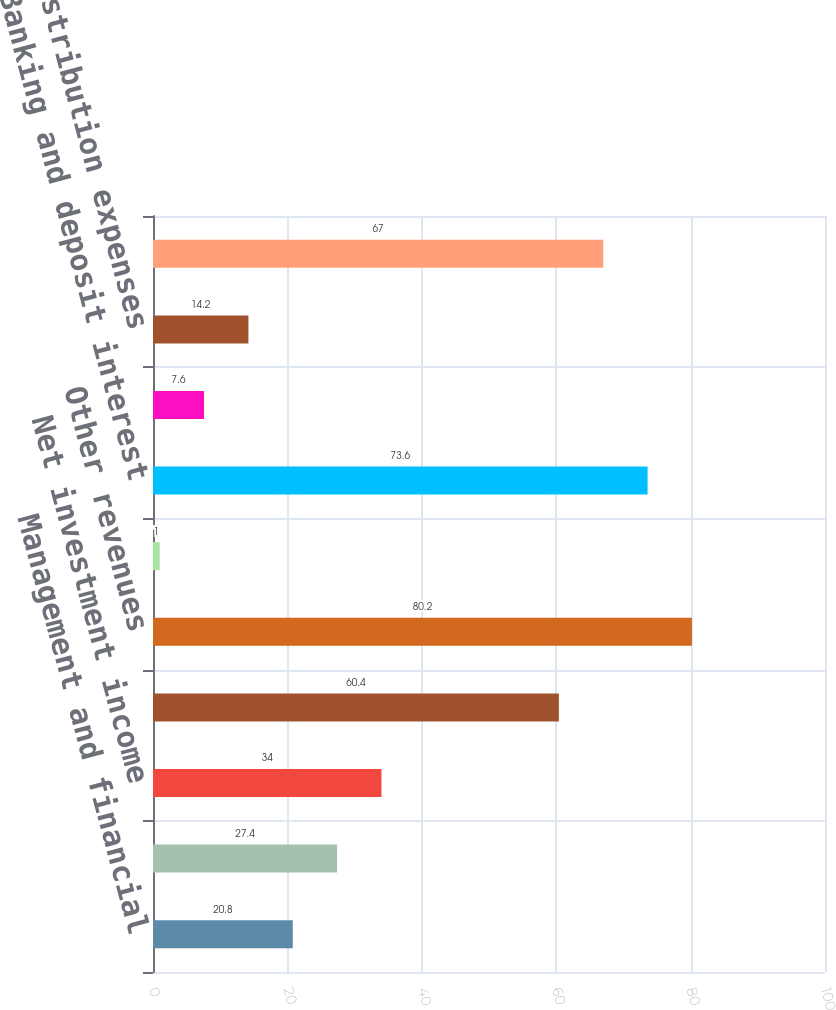Convert chart. <chart><loc_0><loc_0><loc_500><loc_500><bar_chart><fcel>Management and financial<fcel>Distribution fees<fcel>Net investment income<fcel>Premiums<fcel>Other revenues<fcel>Total revenues<fcel>Banking and deposit interest<fcel>Total net revenues<fcel>Distribution expenses<fcel>Interest credited to fixed<nl><fcel>20.8<fcel>27.4<fcel>34<fcel>60.4<fcel>80.2<fcel>1<fcel>73.6<fcel>7.6<fcel>14.2<fcel>67<nl></chart> 